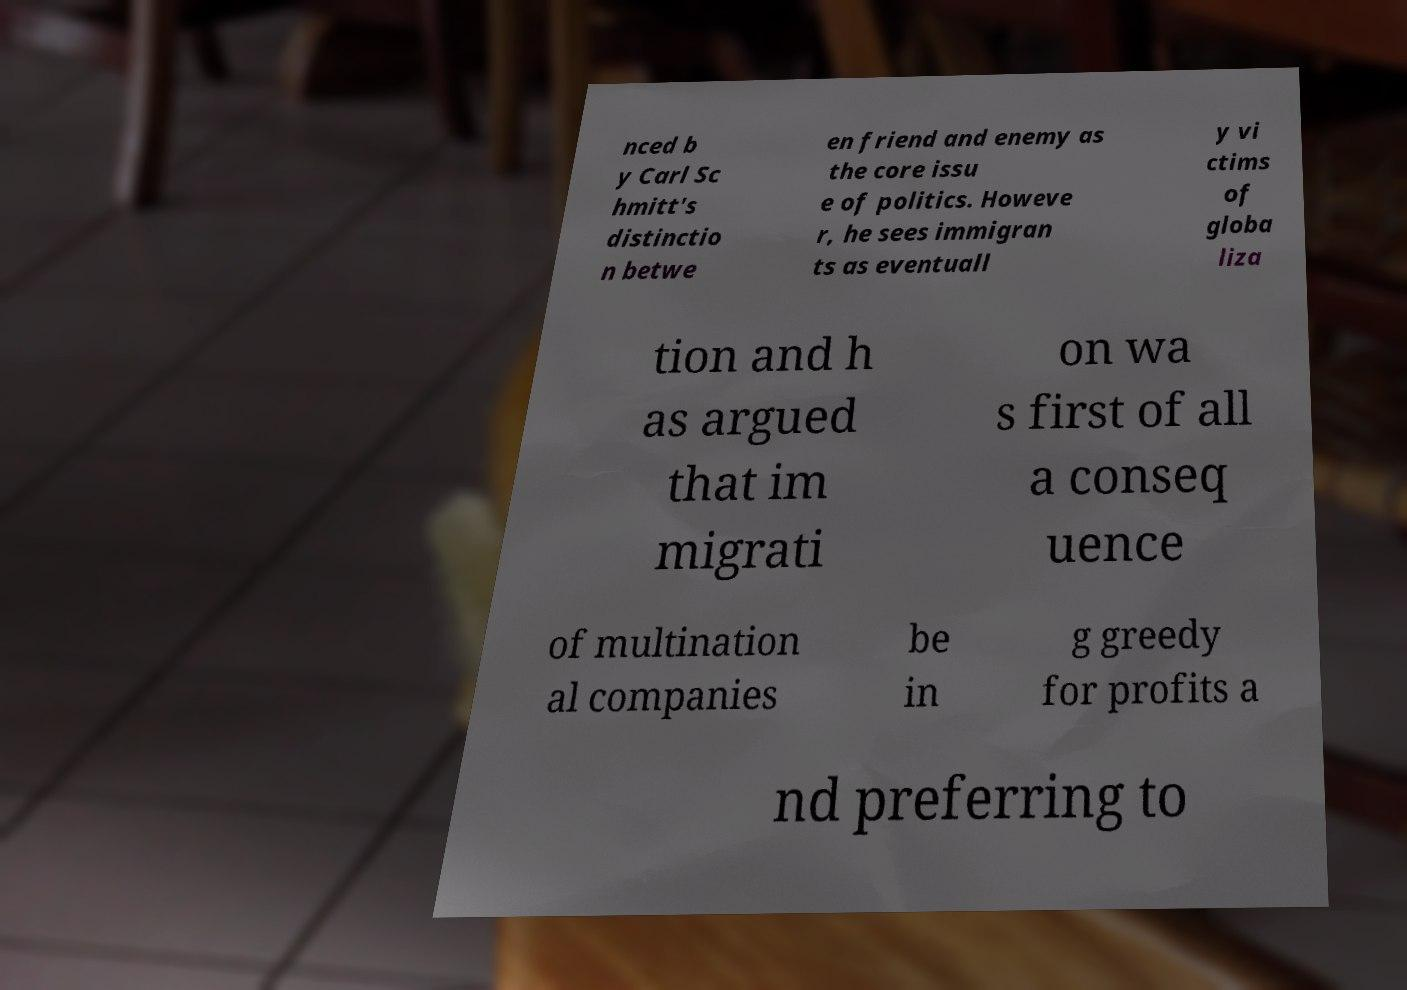Please read and relay the text visible in this image. What does it say? nced b y Carl Sc hmitt's distinctio n betwe en friend and enemy as the core issu e of politics. Howeve r, he sees immigran ts as eventuall y vi ctims of globa liza tion and h as argued that im migrati on wa s first of all a conseq uence of multination al companies be in g greedy for profits a nd preferring to 